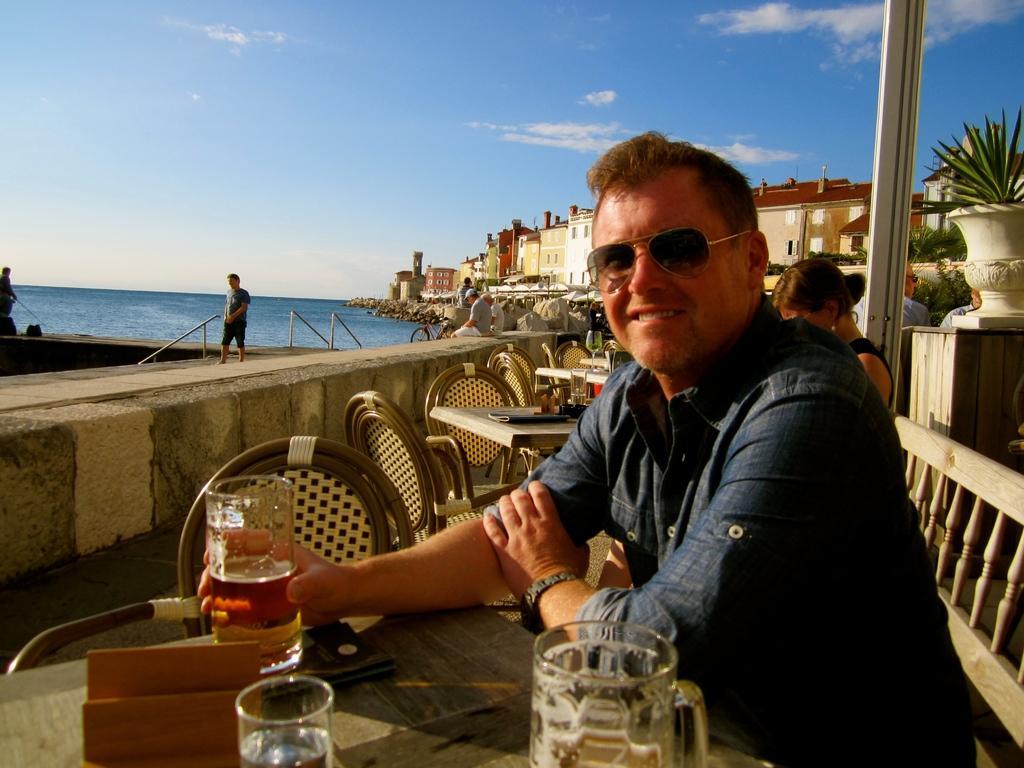Please provide a concise description of this image. This image is taken outdoors. At the top of the image there is a sky with clouds. In the background there are a few houses and buildings and there is a sea. On the right side of the image a man and a woman are sitting on the chairs and there are a few tables with many things on them. There is a plant in the pot and a man is standing on the floor. On the left side of the image a man is walking on the sidewalk and a man is sitting on the wall. 